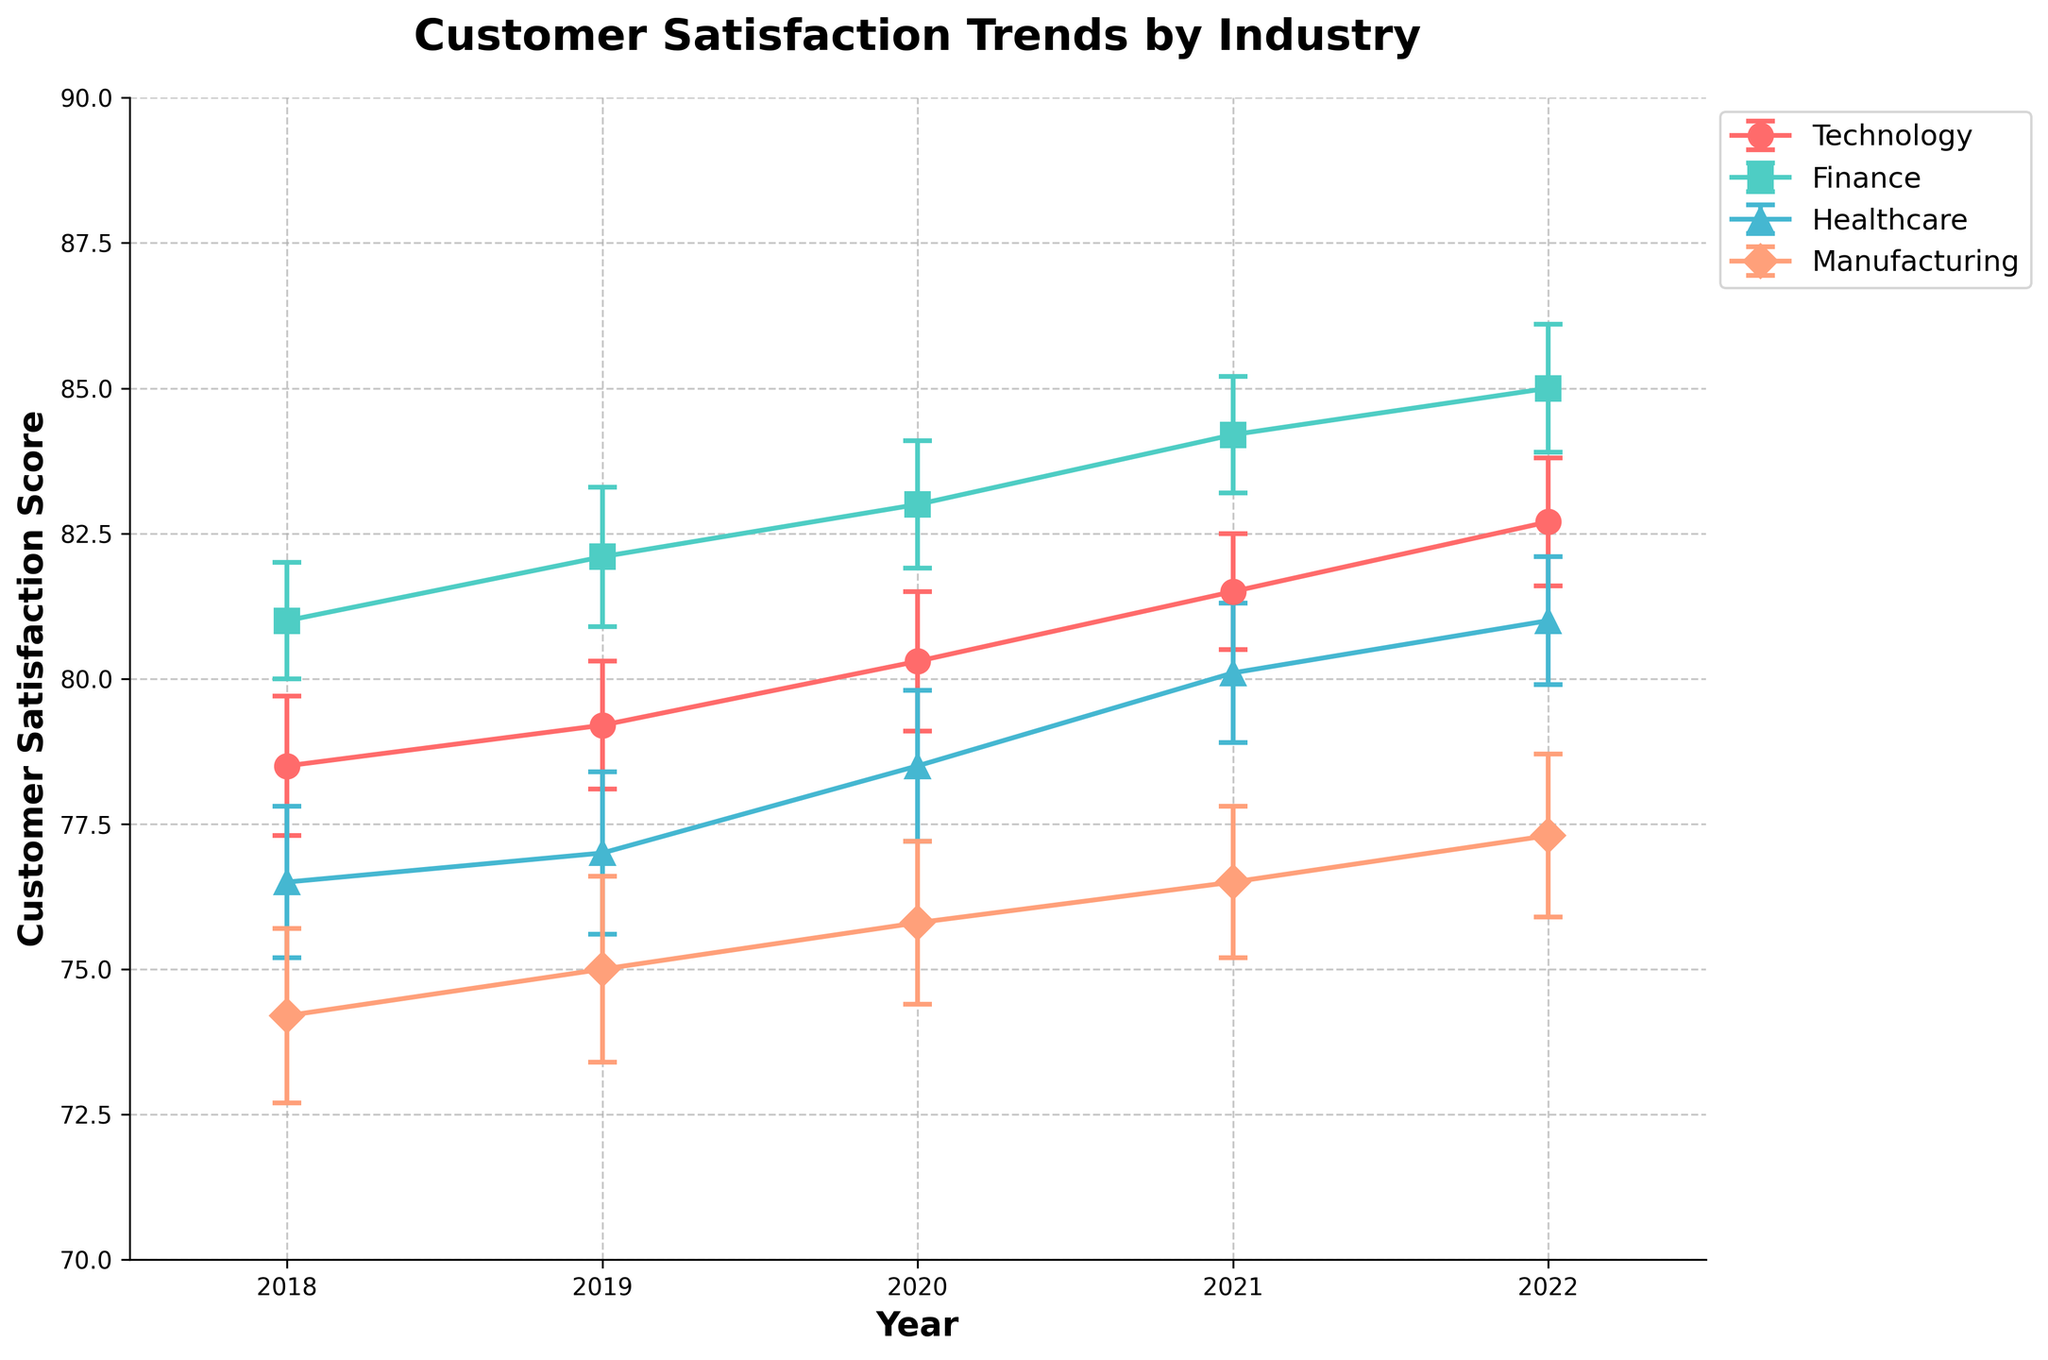What is the title of the figure? The title of the figure appears at the top in a larger, bold font. It summarizes the content of the figure.
Answer: Customer Satisfaction Trends by Industry Which industry had the highest customer satisfaction in 2022? To find this, look at the points corresponding to 2022 for each industry. The highest point represents the industry with the highest satisfaction.
Answer: Finance How has customer satisfaction in the Technology industry changed from 2018 to 2022? Identify and compare the points for Technology from 2018 to 2022. Note the numerical values to understand the trend.
Answer: Increased Which year saw the largest increase in customer satisfaction for the Healthcare industry? Calculate the difference in satisfaction scores between consecutive years for Healthcare and identify where the increase was largest.
Answer: 2020 to 2021 What can be inferred from the error bars in the Manufacturing industry in 2021? The error bars represent the uncertainty or standard error of the satisfaction score in that year. Shorter error bars mean more precise measurements.
Answer: The measurements are relatively precise Compare the customer satisfaction trends between Finance and Manufacturing from 2018 to 2022. Look at the lines representing Finance and Manufacturing from 2018 to 2022, noting which line is higher and any crossing points to infer relative changes.
Answer: Finance consistently higher What range of customer satisfaction scores did the Manufacturing industry experience in 2018? Using the error bars, calculate the range by subtracting and adding the standard error to the mean satisfaction score.
Answer: 72.7 to 75.7 Is there a year where all industries saw an increase in customer satisfaction compared to the previous year? Compare the satisfaction scores year over year for each industry and find any year where all industries showed a positive change.
Answer: 2020 Which industry had the most significant change in satisfaction from 2018 to 2022? Calculate the difference between the 2022 and 2018 scores for each industry and identify the industry with the largest difference.
Answer: Finance What trends can be observed for the Healthcare industry during the given years? Analyze the line representing Healthcare and its overall trajectory from the start year to the end year, noting any periods of increase or decrease.
Answer: Overall increase 